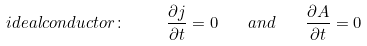<formula> <loc_0><loc_0><loc_500><loc_500>i d e a l c o n d u c t o r \colon \ \quad \frac { \partial { j } } { \partial t } = 0 \quad a n d \quad \frac { \partial { A } } { \partial t } = 0</formula> 